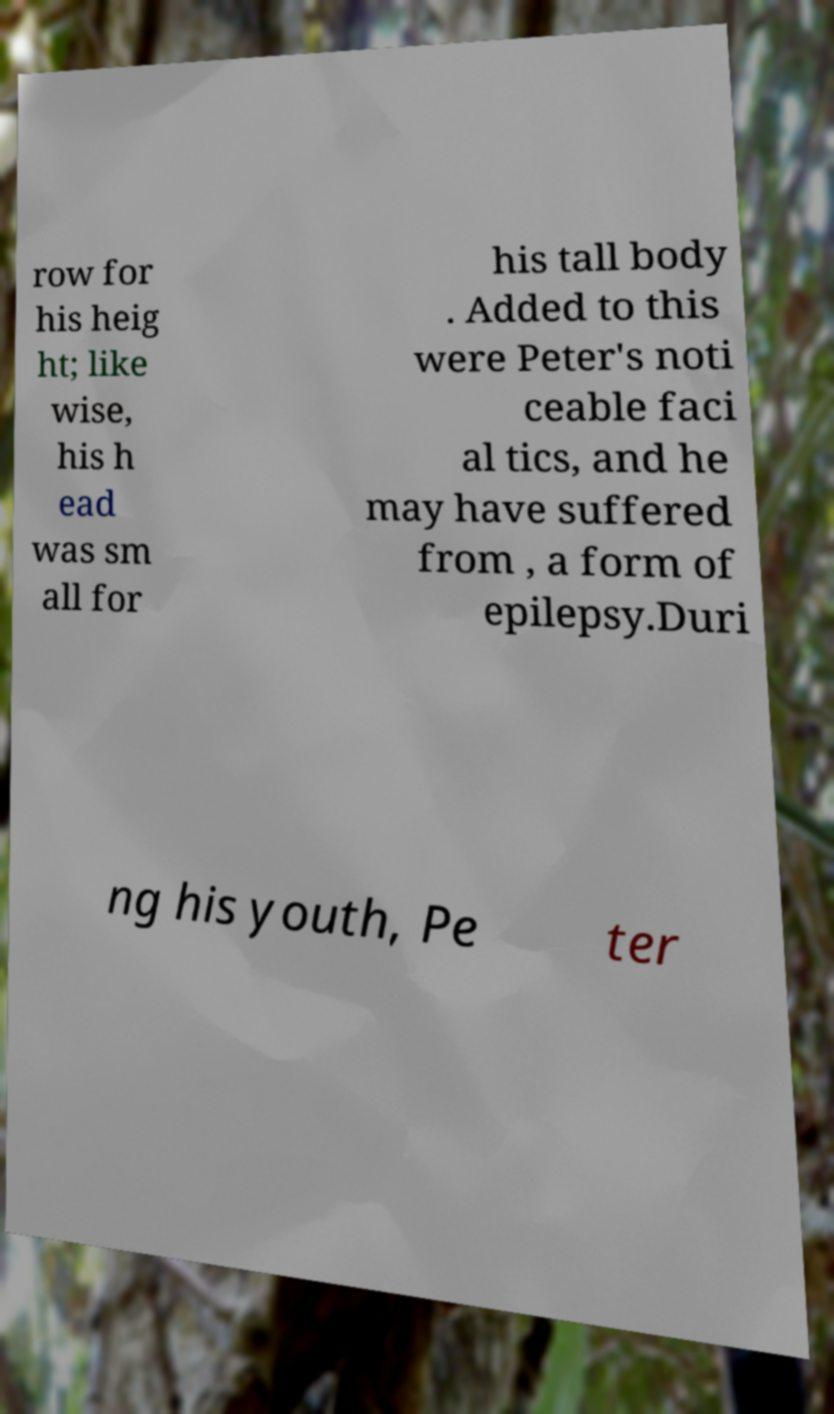Can you read and provide the text displayed in the image?This photo seems to have some interesting text. Can you extract and type it out for me? row for his heig ht; like wise, his h ead was sm all for his tall body . Added to this were Peter's noti ceable faci al tics, and he may have suffered from , a form of epilepsy.Duri ng his youth, Pe ter 